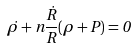<formula> <loc_0><loc_0><loc_500><loc_500>\dot { \rho } + n \frac { \dot { R } } { R } ( \rho + P ) = 0</formula> 